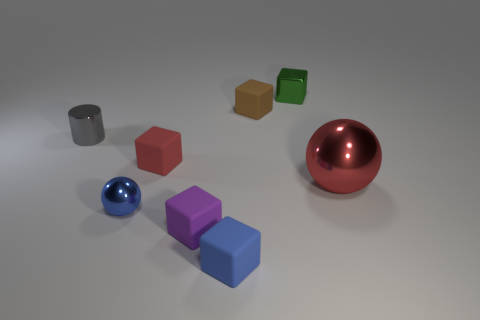Subtract all purple blocks. How many blocks are left? 4 Subtract all brown matte blocks. How many blocks are left? 4 Subtract all blue cubes. Subtract all red spheres. How many cubes are left? 4 Add 1 red things. How many objects exist? 9 Subtract all cylinders. How many objects are left? 7 Add 3 blue cubes. How many blue cubes exist? 4 Subtract 0 green cylinders. How many objects are left? 8 Subtract all large brown balls. Subtract all red metallic balls. How many objects are left? 7 Add 3 tiny gray objects. How many tiny gray objects are left? 4 